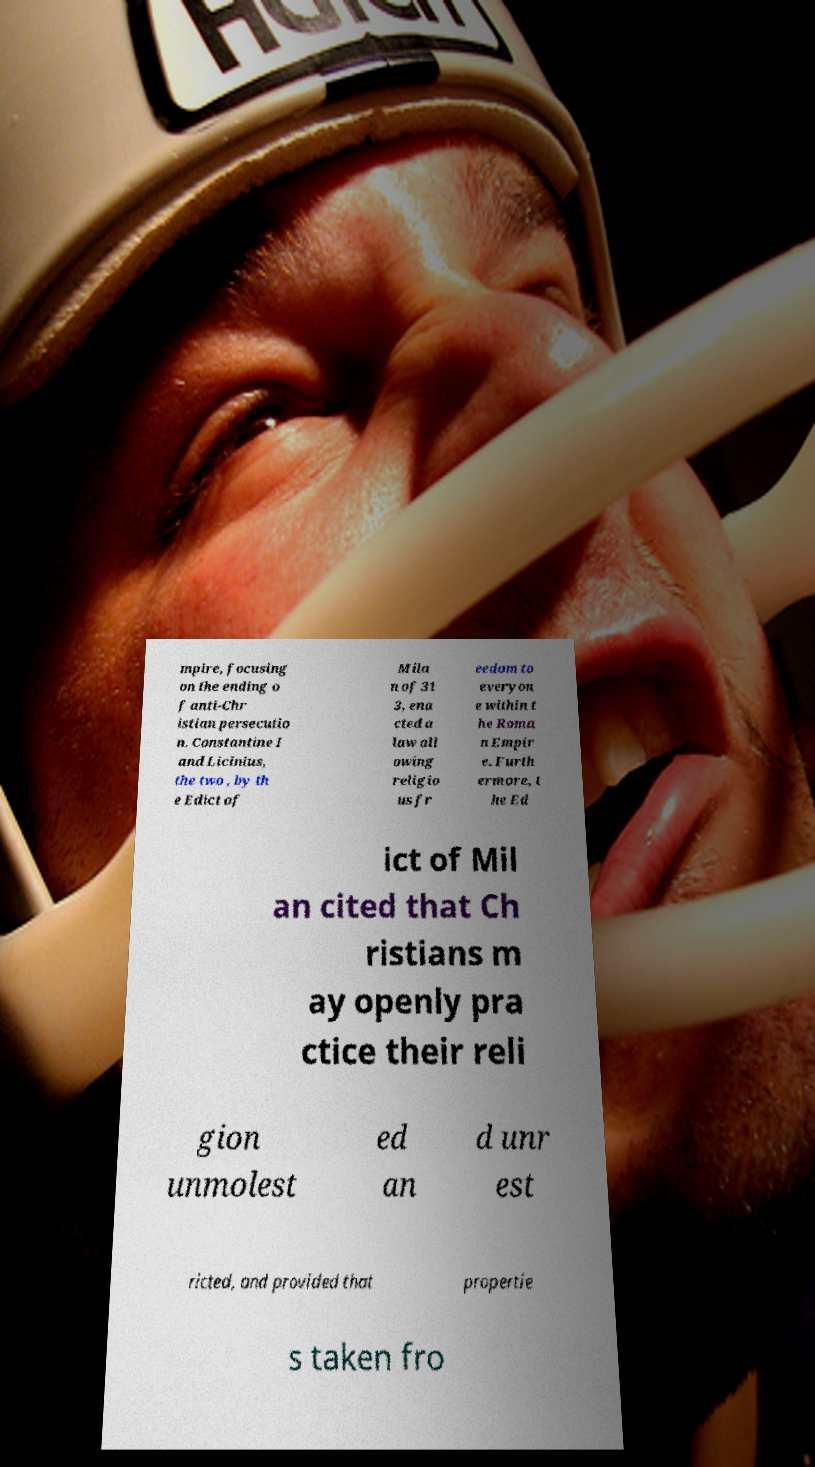I need the written content from this picture converted into text. Can you do that? mpire, focusing on the ending o f anti-Chr istian persecutio n. Constantine I and Licinius, the two , by th e Edict of Mila n of 31 3, ena cted a law all owing religio us fr eedom to everyon e within t he Roma n Empir e. Furth ermore, t he Ed ict of Mil an cited that Ch ristians m ay openly pra ctice their reli gion unmolest ed an d unr est ricted, and provided that propertie s taken fro 